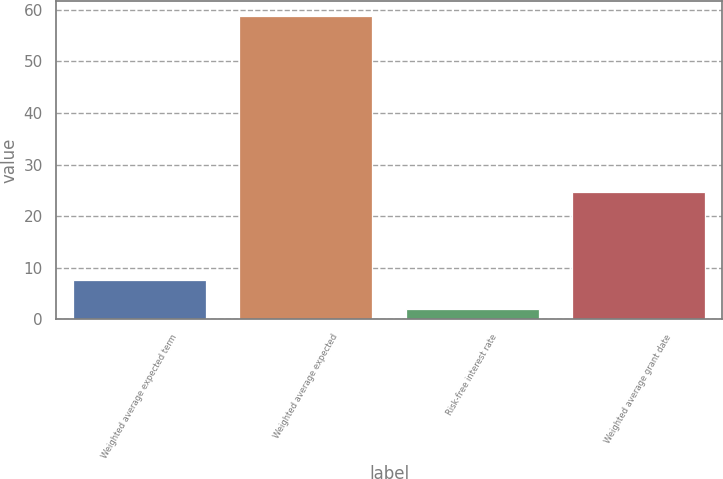Convert chart. <chart><loc_0><loc_0><loc_500><loc_500><bar_chart><fcel>Weighted average expected term<fcel>Weighted average expected<fcel>Risk-free interest rate<fcel>Weighted average grant date<nl><fcel>7.68<fcel>58.8<fcel>2<fcel>24.61<nl></chart> 